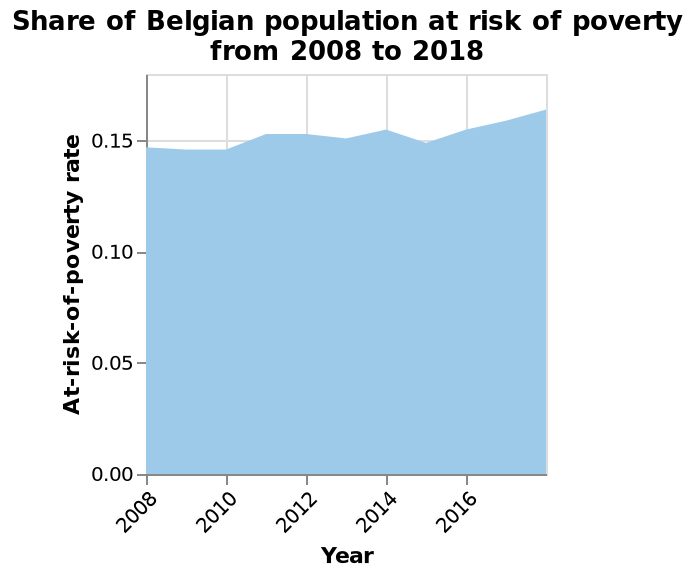<image>
please enumerates aspects of the construction of the chart Here a is a area chart named Share of Belgian population at risk of poverty from 2008 to 2018. Year is measured on the x-axis. There is a scale with a minimum of 0.00 and a maximum of 0.15 along the y-axis, labeled At-risk-of-poverty rate. What was the overall trend of the at-risk-of-poverty rate in Belgium from 2015 to 2016? The at-risk-of-poverty rate in Belgium steadily climbed once again through 2015 and 2016. Did the at-risk-of-poverty rate in Belgium increase or decrease in 2011?  The at-risk-of-poverty rate in Belgium rose slightly in 2011. Did the at-risk-of-poverty rate in Belgium rapidly drop once again through 2015 and 2016? No.The at-risk-of-poverty rate in Belgium steadily climbed once again through 2015 and 2016. 